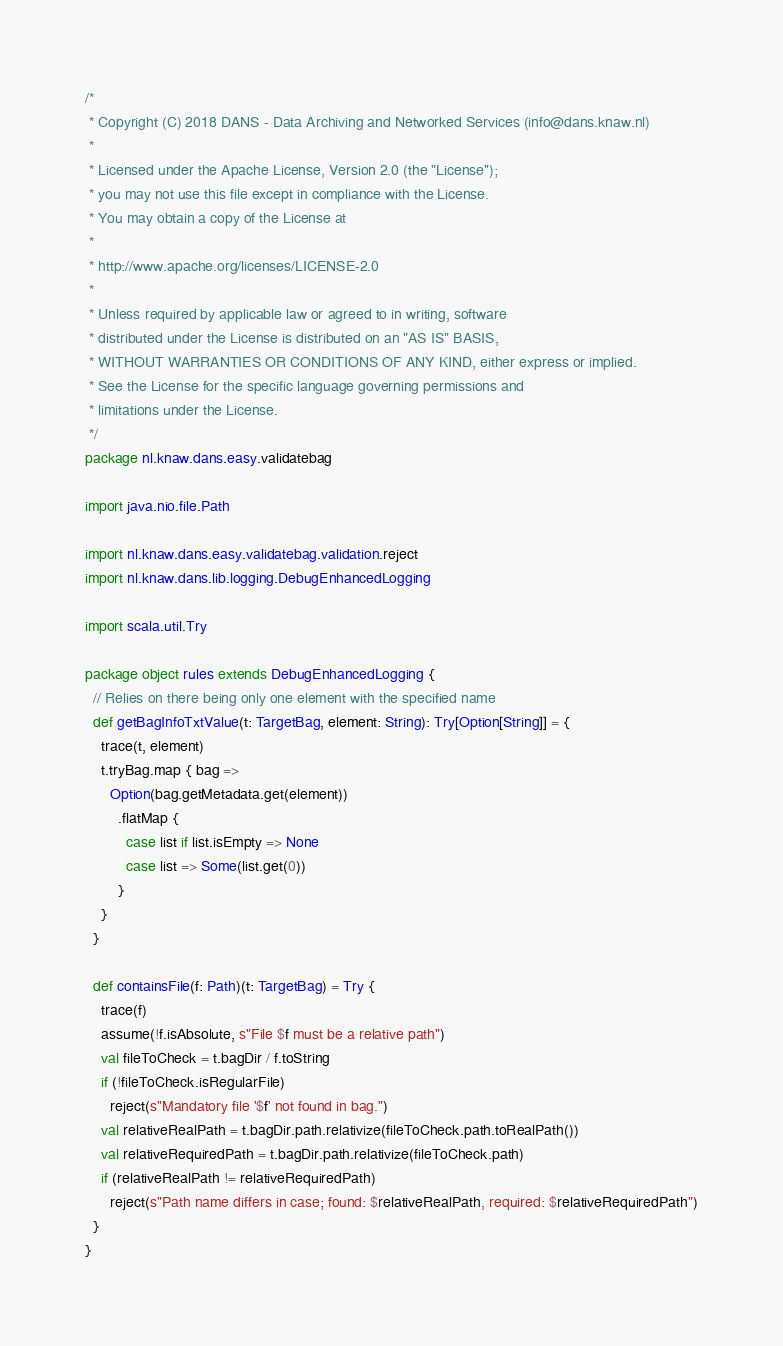<code> <loc_0><loc_0><loc_500><loc_500><_Scala_>/*
 * Copyright (C) 2018 DANS - Data Archiving and Networked Services (info@dans.knaw.nl)
 *
 * Licensed under the Apache License, Version 2.0 (the "License");
 * you may not use this file except in compliance with the License.
 * You may obtain a copy of the License at
 *
 * http://www.apache.org/licenses/LICENSE-2.0
 *
 * Unless required by applicable law or agreed to in writing, software
 * distributed under the License is distributed on an "AS IS" BASIS,
 * WITHOUT WARRANTIES OR CONDITIONS OF ANY KIND, either express or implied.
 * See the License for the specific language governing permissions and
 * limitations under the License.
 */
package nl.knaw.dans.easy.validatebag

import java.nio.file.Path

import nl.knaw.dans.easy.validatebag.validation.reject
import nl.knaw.dans.lib.logging.DebugEnhancedLogging

import scala.util.Try

package object rules extends DebugEnhancedLogging {
  // Relies on there being only one element with the specified name
  def getBagInfoTxtValue(t: TargetBag, element: String): Try[Option[String]] = {
    trace(t, element)
    t.tryBag.map { bag =>
      Option(bag.getMetadata.get(element))
        .flatMap {
          case list if list.isEmpty => None
          case list => Some(list.get(0))
        }
    }
  }

  def containsFile(f: Path)(t: TargetBag) = Try {
    trace(f)
    assume(!f.isAbsolute, s"File $f must be a relative path")
    val fileToCheck = t.bagDir / f.toString
    if (!fileToCheck.isRegularFile)
      reject(s"Mandatory file '$f' not found in bag.")
    val relativeRealPath = t.bagDir.path.relativize(fileToCheck.path.toRealPath())
    val relativeRequiredPath = t.bagDir.path.relativize(fileToCheck.path)
    if (relativeRealPath != relativeRequiredPath)
      reject(s"Path name differs in case; found: $relativeRealPath, required: $relativeRequiredPath")
  }
}
</code> 